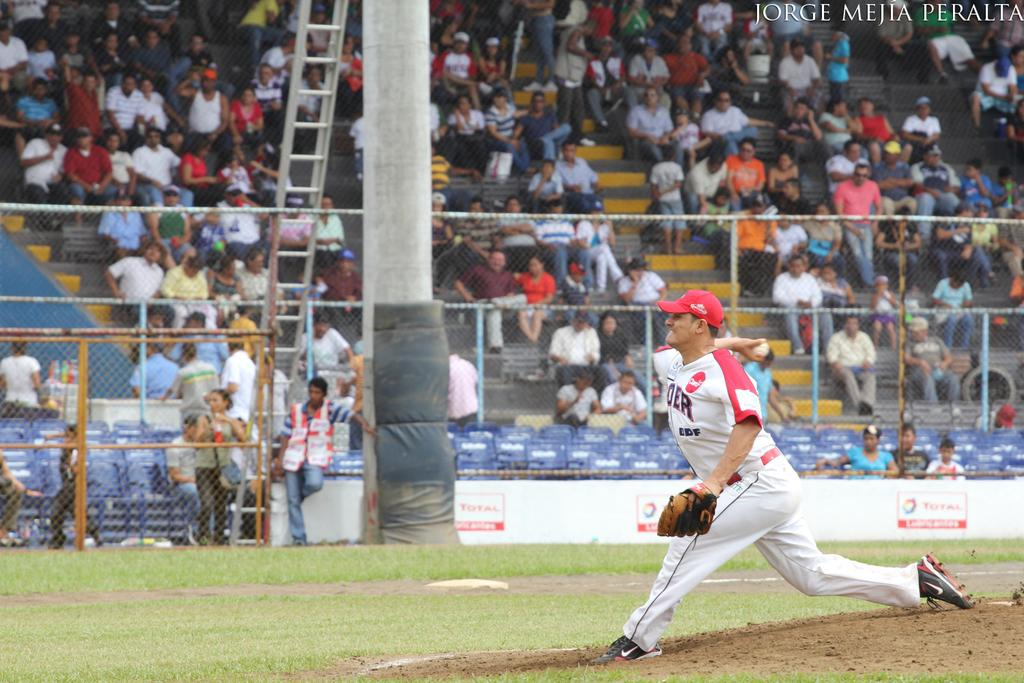Provide a one-sentence caption for the provided image. A pitcher thows the ball in front of a crowd in this photo that says Jorge Mejia Peralta in the upper corner. 